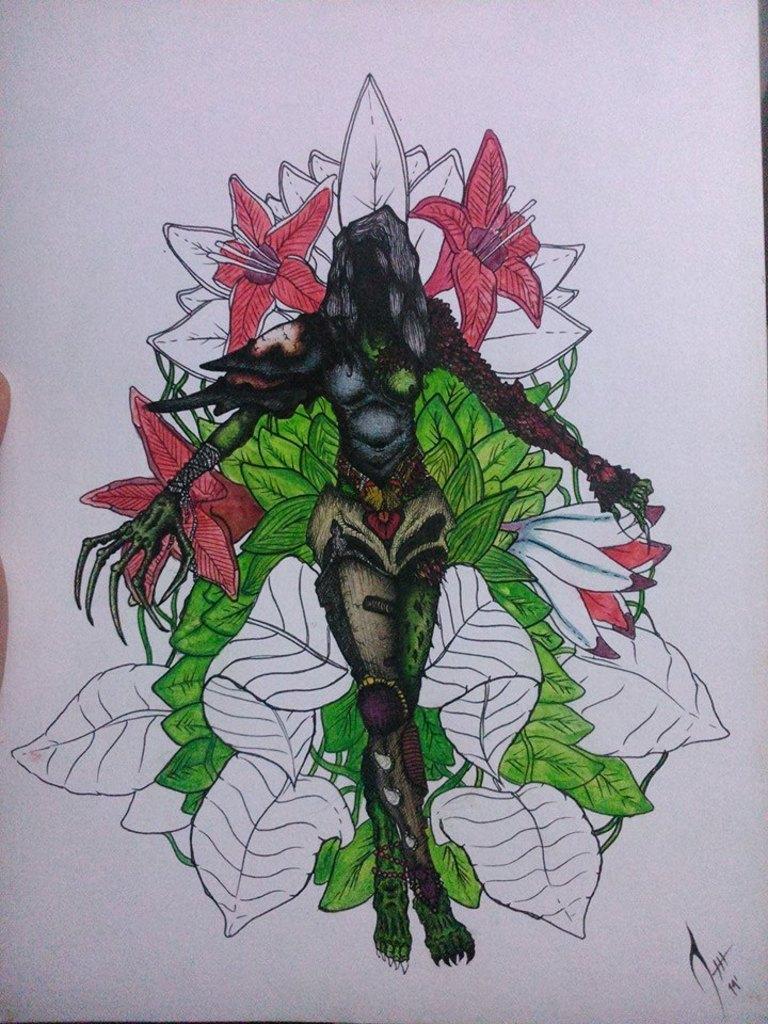Could you give a brief overview of what you see in this image? In this image I can see white color paper and on it I can see a drawing. I can see color of this drawing is green, black and orange. 